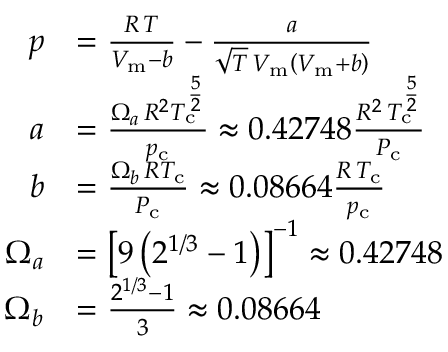<formula> <loc_0><loc_0><loc_500><loc_500>{ \begin{array} { r l } { p } & { = { \frac { R \, T } { V _ { m } - b } } - { \frac { a } { { \sqrt { T } } \, V _ { m } \left ( V _ { m } + b \right ) } } } \\ { a } & { = { \frac { \Omega _ { a } \, R ^ { 2 } T _ { c } ^ { \frac { 5 } { 2 } } } { p _ { c } } } \approx 0 . 4 2 7 4 8 { \frac { R ^ { 2 } \, T _ { c } ^ { \frac { 5 } { 2 } } } { P _ { c } } } } \\ { b } & { = { \frac { \Omega _ { b } \, R T _ { c } } { P _ { c } } } \approx 0 . 0 8 6 6 4 { \frac { R \, T _ { c } } { p _ { c } } } } \\ { \Omega _ { a } } & { = \left [ 9 \left ( 2 ^ { 1 / 3 } - 1 \right ) \right ] ^ { - 1 } \approx 0 . 4 2 7 4 8 } \\ { \Omega _ { b } } & { = { \frac { 2 ^ { 1 / 3 } - 1 } { 3 } } \approx 0 . 0 8 6 6 4 } \end{array} }</formula> 